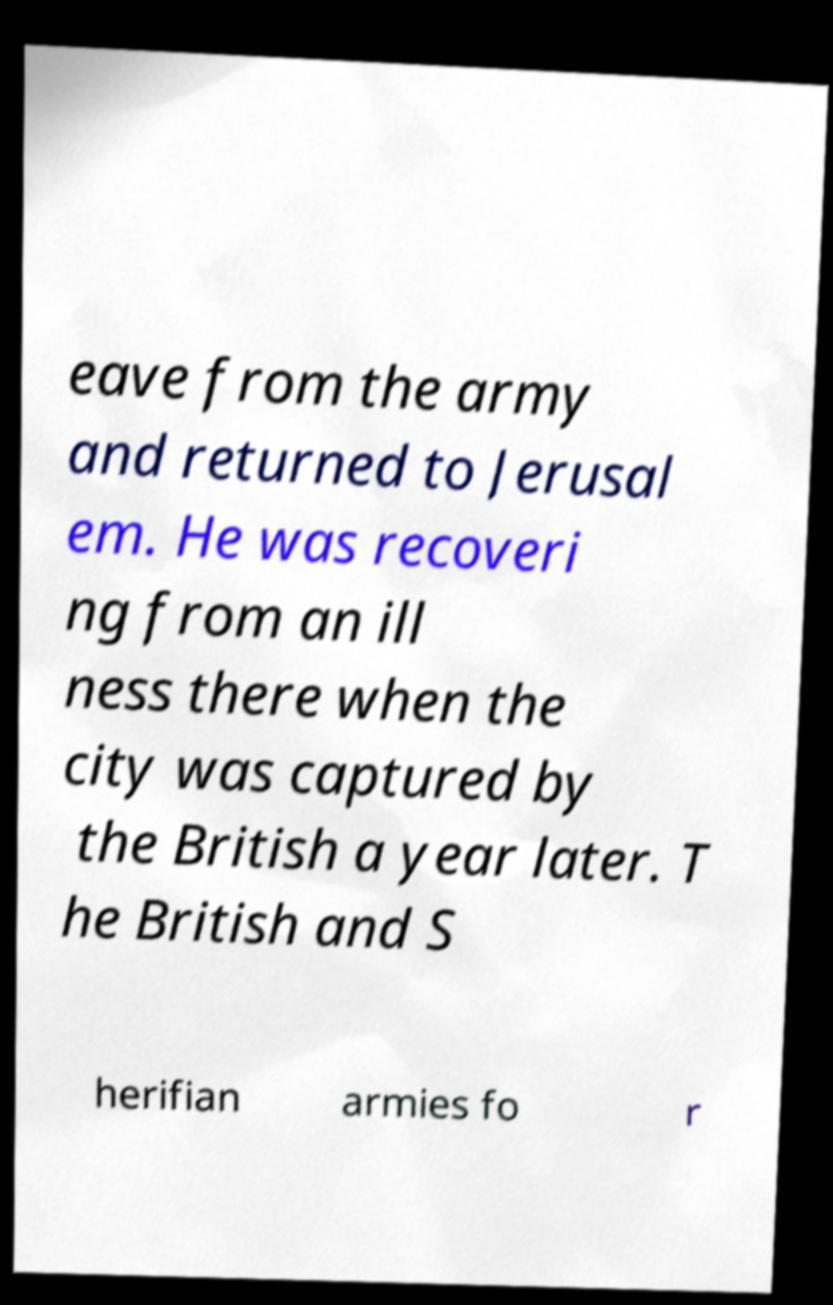Please read and relay the text visible in this image. What does it say? eave from the army and returned to Jerusal em. He was recoveri ng from an ill ness there when the city was captured by the British a year later. T he British and S herifian armies fo r 